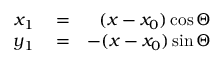Convert formula to latex. <formula><loc_0><loc_0><loc_500><loc_500>\begin{array} { r l r } { x _ { 1 } } & = } & { ( x - x _ { 0 } ) \cos \Theta } \\ { y _ { 1 } } & = } & { - ( x - x _ { 0 } ) \sin \Theta } \end{array}</formula> 